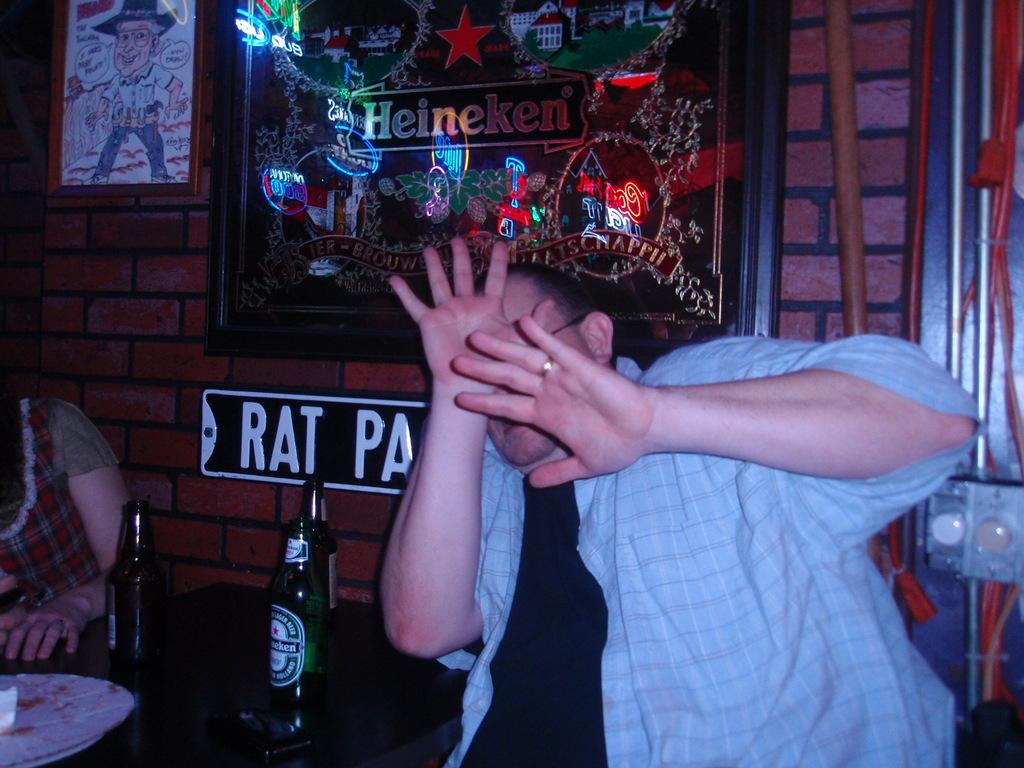Who are the people in the image? There is a man and a woman in the image. Where are the people located in the image? They are sitting in the foreground area. What can be seen on the table in the image? There are bottles on a table. What is visible in the background of the image? There are posters in the background. What type of instrument is the man playing in the image? There is no instrument present in the image; the man and woman are simply sitting. What design can be seen on the butter in the image? There is no butter present in the image, so it is not possible to determine its design. 